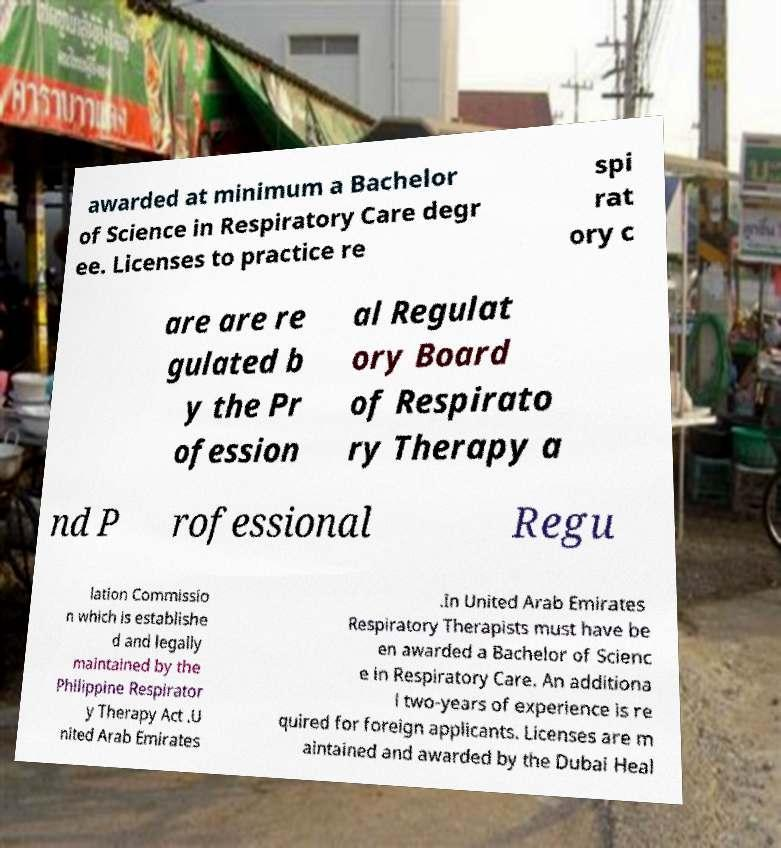Could you extract and type out the text from this image? awarded at minimum a Bachelor of Science in Respiratory Care degr ee. Licenses to practice re spi rat ory c are are re gulated b y the Pr ofession al Regulat ory Board of Respirato ry Therapy a nd P rofessional Regu lation Commissio n which is establishe d and legally maintained by the Philippine Respirator y Therapy Act .U nited Arab Emirates .In United Arab Emirates Respiratory Therapists must have be en awarded a Bachelor of Scienc e in Respiratory Care. An additiona l two-years of experience is re quired for foreign applicants. Licenses are m aintained and awarded by the Dubai Heal 